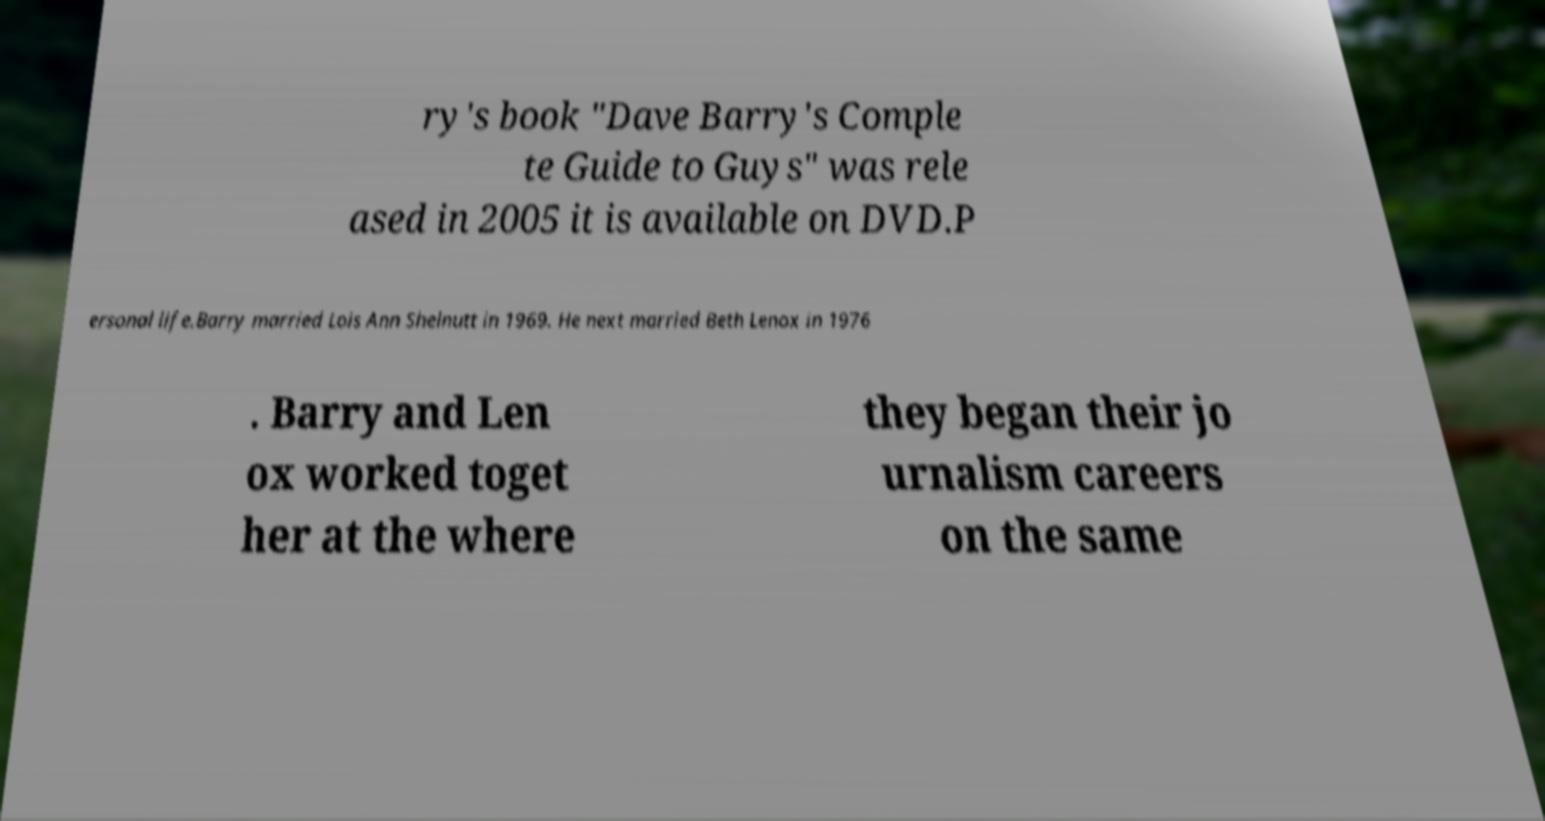Could you extract and type out the text from this image? ry's book "Dave Barry's Comple te Guide to Guys" was rele ased in 2005 it is available on DVD.P ersonal life.Barry married Lois Ann Shelnutt in 1969. He next married Beth Lenox in 1976 . Barry and Len ox worked toget her at the where they began their jo urnalism careers on the same 